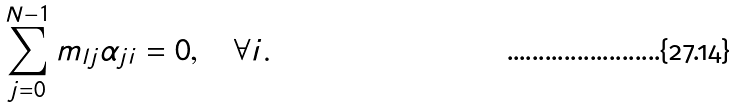Convert formula to latex. <formula><loc_0><loc_0><loc_500><loc_500>\sum _ { j = 0 } ^ { N - 1 } m _ { l j } \alpha _ { j i } = 0 , \quad \forall i .</formula> 